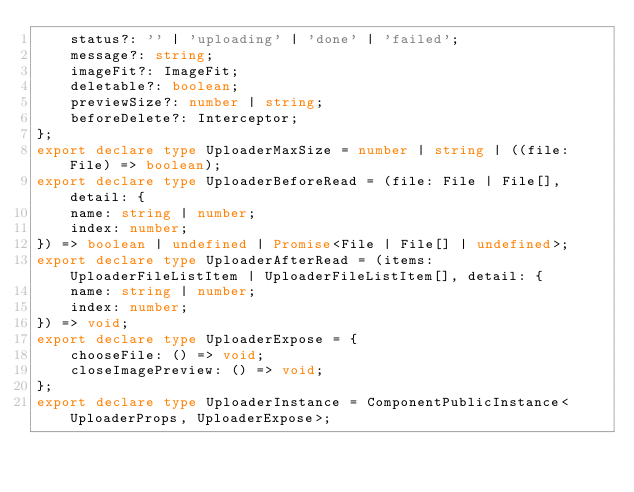Convert code to text. <code><loc_0><loc_0><loc_500><loc_500><_TypeScript_>    status?: '' | 'uploading' | 'done' | 'failed';
    message?: string;
    imageFit?: ImageFit;
    deletable?: boolean;
    previewSize?: number | string;
    beforeDelete?: Interceptor;
};
export declare type UploaderMaxSize = number | string | ((file: File) => boolean);
export declare type UploaderBeforeRead = (file: File | File[], detail: {
    name: string | number;
    index: number;
}) => boolean | undefined | Promise<File | File[] | undefined>;
export declare type UploaderAfterRead = (items: UploaderFileListItem | UploaderFileListItem[], detail: {
    name: string | number;
    index: number;
}) => void;
export declare type UploaderExpose = {
    chooseFile: () => void;
    closeImagePreview: () => void;
};
export declare type UploaderInstance = ComponentPublicInstance<UploaderProps, UploaderExpose>;
</code> 